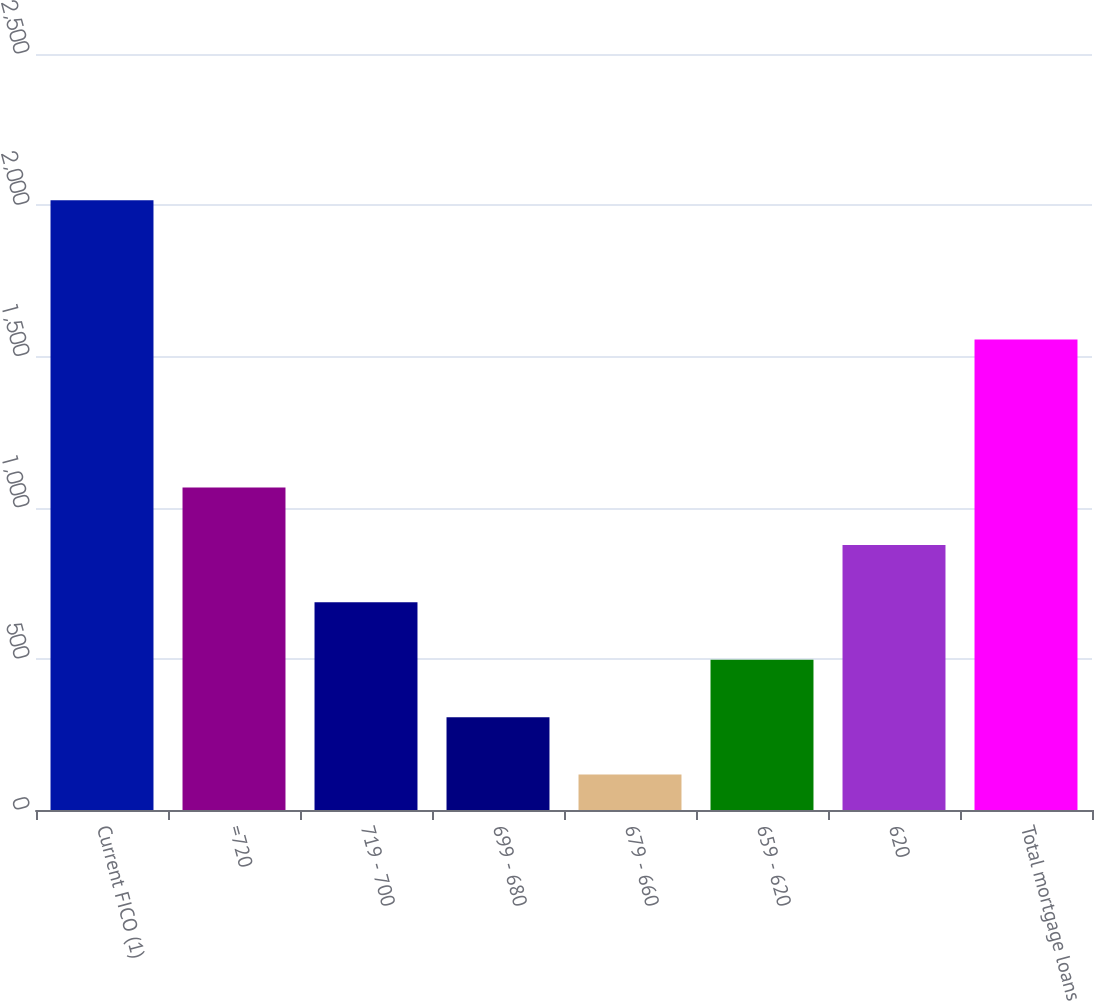Convert chart. <chart><loc_0><loc_0><loc_500><loc_500><bar_chart><fcel>Current FICO (1)<fcel>=720<fcel>719 - 700<fcel>699 - 680<fcel>679 - 660<fcel>659 - 620<fcel>620<fcel>Total mortgage loans<nl><fcel>2016<fcel>1066.5<fcel>686.7<fcel>306.9<fcel>117<fcel>496.8<fcel>876.6<fcel>1556<nl></chart> 